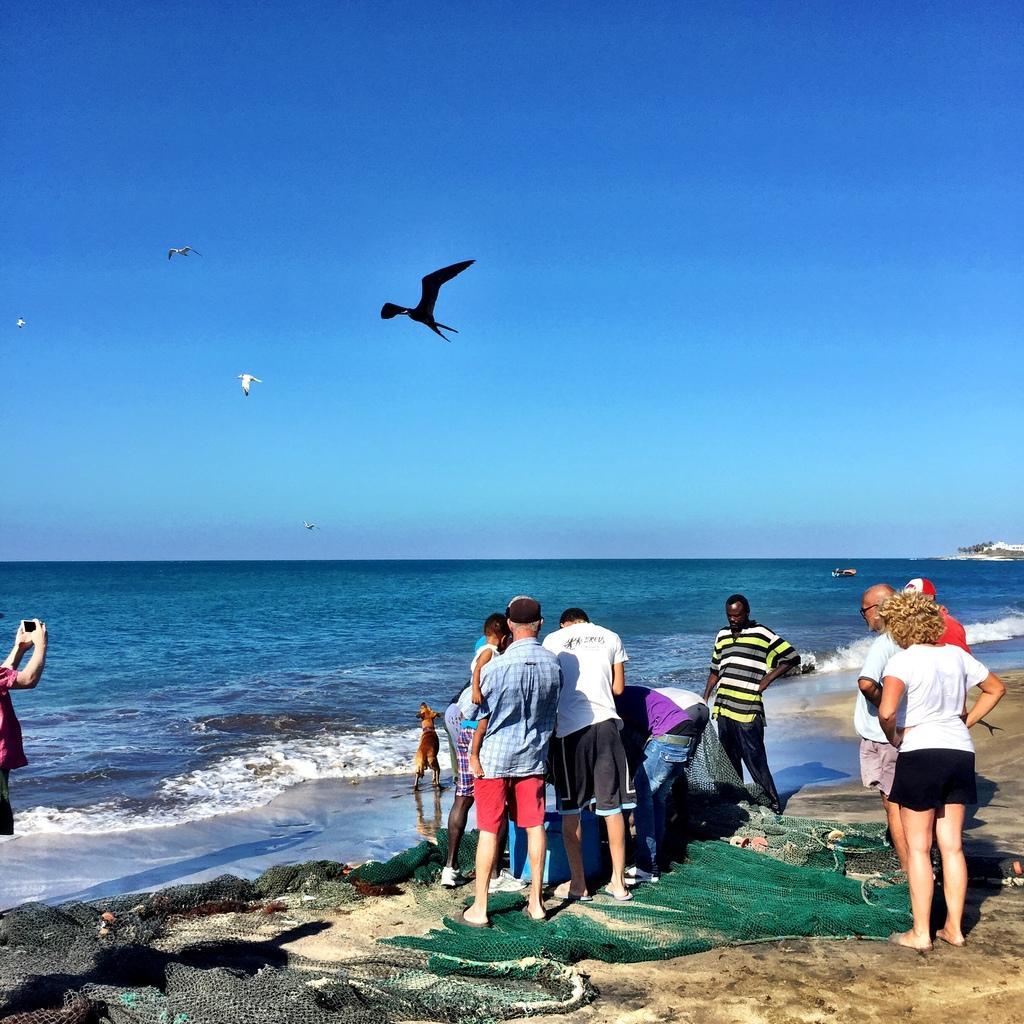In one or two sentences, can you explain what this image depicts? In front of the picture, we see people are standing. Beside them, we see a green net. I think they might be fishing. The man on the left side is holding the mobile phone or the camera and he is clicking the photos. In the middle of the picture, we see water and this water might be in the sea. At the top, we see the birds flying in the sky. This picture is clicked at the seashore. 